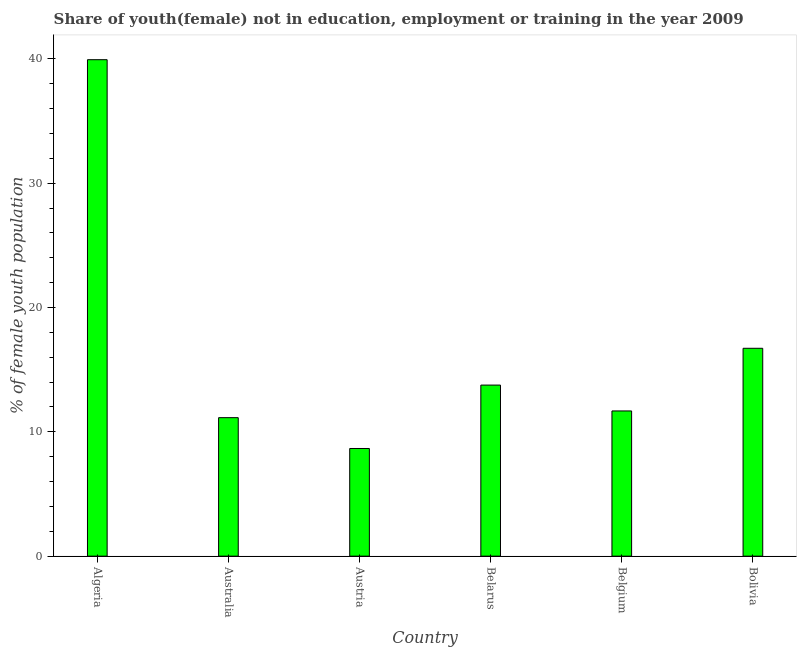What is the title of the graph?
Your answer should be compact. Share of youth(female) not in education, employment or training in the year 2009. What is the label or title of the X-axis?
Your response must be concise. Country. What is the label or title of the Y-axis?
Your response must be concise. % of female youth population. What is the unemployed female youth population in Belgium?
Keep it short and to the point. 11.68. Across all countries, what is the maximum unemployed female youth population?
Keep it short and to the point. 39.93. Across all countries, what is the minimum unemployed female youth population?
Provide a succinct answer. 8.66. In which country was the unemployed female youth population maximum?
Ensure brevity in your answer.  Algeria. In which country was the unemployed female youth population minimum?
Keep it short and to the point. Austria. What is the sum of the unemployed female youth population?
Your answer should be very brief. 101.89. What is the difference between the unemployed female youth population in Austria and Belgium?
Provide a short and direct response. -3.02. What is the average unemployed female youth population per country?
Provide a short and direct response. 16.98. What is the median unemployed female youth population?
Offer a terse response. 12.72. What is the ratio of the unemployed female youth population in Algeria to that in Belgium?
Offer a terse response. 3.42. Is the difference between the unemployed female youth population in Austria and Belarus greater than the difference between any two countries?
Ensure brevity in your answer.  No. What is the difference between the highest and the second highest unemployed female youth population?
Your answer should be compact. 23.21. What is the difference between the highest and the lowest unemployed female youth population?
Keep it short and to the point. 31.27. In how many countries, is the unemployed female youth population greater than the average unemployed female youth population taken over all countries?
Your response must be concise. 1. How many bars are there?
Your response must be concise. 6. How many countries are there in the graph?
Make the answer very short. 6. What is the difference between two consecutive major ticks on the Y-axis?
Make the answer very short. 10. Are the values on the major ticks of Y-axis written in scientific E-notation?
Keep it short and to the point. No. What is the % of female youth population in Algeria?
Your answer should be very brief. 39.93. What is the % of female youth population of Australia?
Offer a very short reply. 11.14. What is the % of female youth population of Austria?
Keep it short and to the point. 8.66. What is the % of female youth population of Belarus?
Offer a very short reply. 13.76. What is the % of female youth population of Belgium?
Provide a succinct answer. 11.68. What is the % of female youth population in Bolivia?
Provide a succinct answer. 16.72. What is the difference between the % of female youth population in Algeria and Australia?
Ensure brevity in your answer.  28.79. What is the difference between the % of female youth population in Algeria and Austria?
Your answer should be very brief. 31.27. What is the difference between the % of female youth population in Algeria and Belarus?
Ensure brevity in your answer.  26.17. What is the difference between the % of female youth population in Algeria and Belgium?
Offer a terse response. 28.25. What is the difference between the % of female youth population in Algeria and Bolivia?
Provide a short and direct response. 23.21. What is the difference between the % of female youth population in Australia and Austria?
Keep it short and to the point. 2.48. What is the difference between the % of female youth population in Australia and Belarus?
Ensure brevity in your answer.  -2.62. What is the difference between the % of female youth population in Australia and Belgium?
Provide a succinct answer. -0.54. What is the difference between the % of female youth population in Australia and Bolivia?
Your answer should be compact. -5.58. What is the difference between the % of female youth population in Austria and Belarus?
Make the answer very short. -5.1. What is the difference between the % of female youth population in Austria and Belgium?
Your answer should be very brief. -3.02. What is the difference between the % of female youth population in Austria and Bolivia?
Ensure brevity in your answer.  -8.06. What is the difference between the % of female youth population in Belarus and Belgium?
Give a very brief answer. 2.08. What is the difference between the % of female youth population in Belarus and Bolivia?
Ensure brevity in your answer.  -2.96. What is the difference between the % of female youth population in Belgium and Bolivia?
Provide a short and direct response. -5.04. What is the ratio of the % of female youth population in Algeria to that in Australia?
Provide a succinct answer. 3.58. What is the ratio of the % of female youth population in Algeria to that in Austria?
Give a very brief answer. 4.61. What is the ratio of the % of female youth population in Algeria to that in Belarus?
Offer a terse response. 2.9. What is the ratio of the % of female youth population in Algeria to that in Belgium?
Provide a short and direct response. 3.42. What is the ratio of the % of female youth population in Algeria to that in Bolivia?
Ensure brevity in your answer.  2.39. What is the ratio of the % of female youth population in Australia to that in Austria?
Your answer should be compact. 1.29. What is the ratio of the % of female youth population in Australia to that in Belarus?
Ensure brevity in your answer.  0.81. What is the ratio of the % of female youth population in Australia to that in Belgium?
Offer a very short reply. 0.95. What is the ratio of the % of female youth population in Australia to that in Bolivia?
Offer a very short reply. 0.67. What is the ratio of the % of female youth population in Austria to that in Belarus?
Give a very brief answer. 0.63. What is the ratio of the % of female youth population in Austria to that in Belgium?
Offer a very short reply. 0.74. What is the ratio of the % of female youth population in Austria to that in Bolivia?
Your response must be concise. 0.52. What is the ratio of the % of female youth population in Belarus to that in Belgium?
Your answer should be compact. 1.18. What is the ratio of the % of female youth population in Belarus to that in Bolivia?
Your response must be concise. 0.82. What is the ratio of the % of female youth population in Belgium to that in Bolivia?
Your response must be concise. 0.7. 